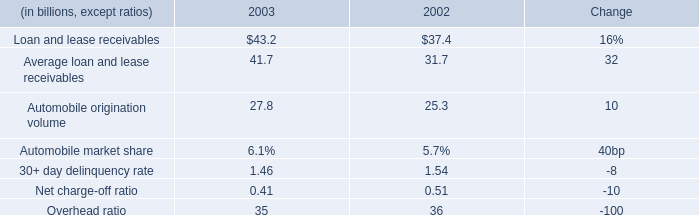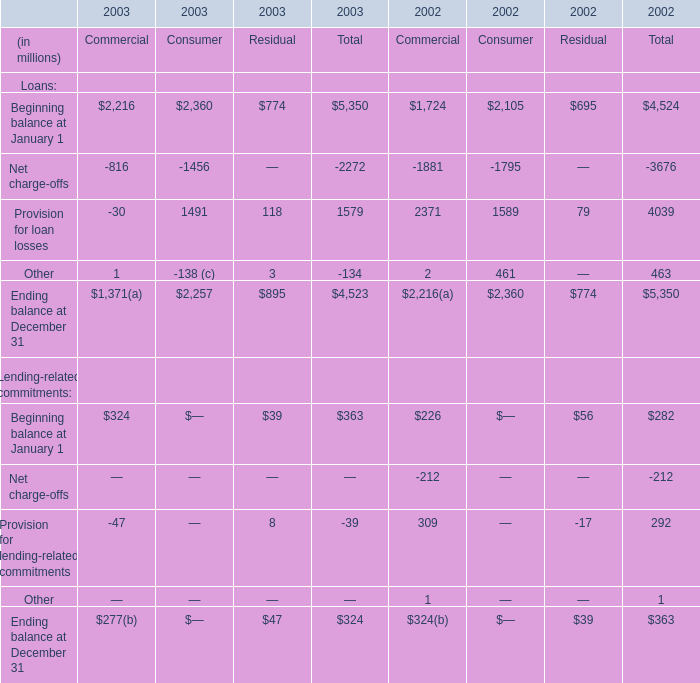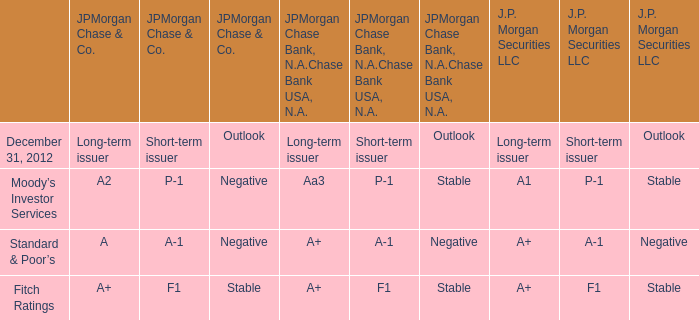What is the growing rate of Other in the year with the most Beginning balance? 
Computations: ((-134 - 463) / 463)
Answer: -1.28942. 